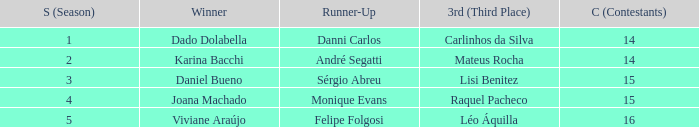Who was the winner when Mateus Rocha finished in 3rd place?  Karina Bacchi. 